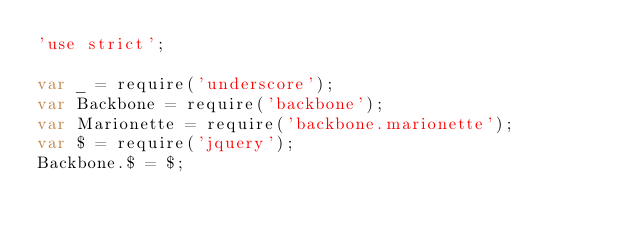Convert code to text. <code><loc_0><loc_0><loc_500><loc_500><_JavaScript_>'use strict';

var _ = require('underscore');
var Backbone = require('backbone');
var Marionette = require('backbone.marionette');
var $ = require('jquery');
Backbone.$ = $;
</code> 